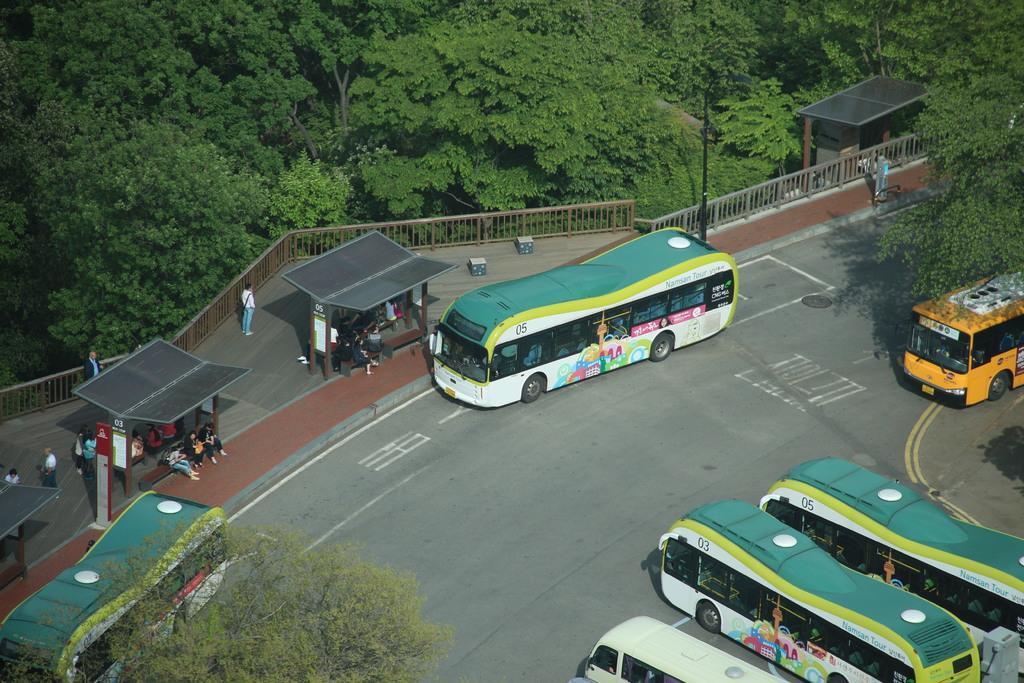In one or two sentences, can you explain what this image depicts? This is an outside view. Here I can see few buses on the road. On the left side there are two sheds, under these I can see few people sitting and also there are few people standing. Beside these sheds there is a railing. On the right side there is another shed. At the top of the image there are many trees. 